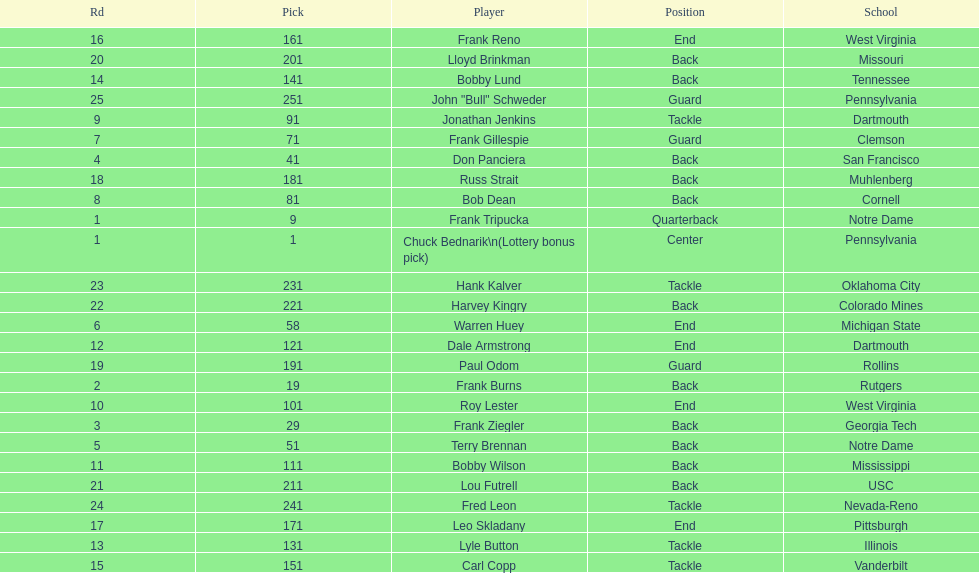Who was picked after roy lester? Bobby Wilson. 